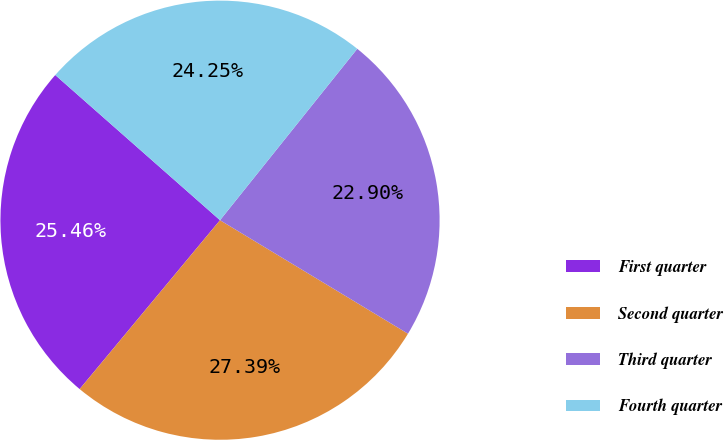Convert chart to OTSL. <chart><loc_0><loc_0><loc_500><loc_500><pie_chart><fcel>First quarter<fcel>Second quarter<fcel>Third quarter<fcel>Fourth quarter<nl><fcel>25.46%<fcel>27.39%<fcel>22.9%<fcel>24.25%<nl></chart> 